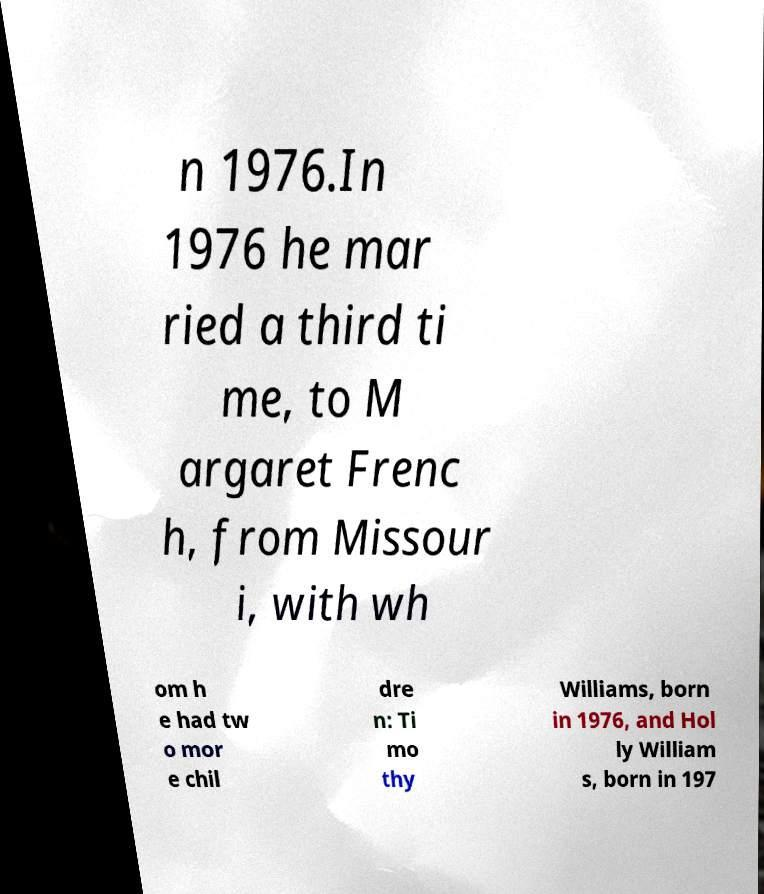Can you read and provide the text displayed in the image?This photo seems to have some interesting text. Can you extract and type it out for me? n 1976.In 1976 he mar ried a third ti me, to M argaret Frenc h, from Missour i, with wh om h e had tw o mor e chil dre n: Ti mo thy Williams, born in 1976, and Hol ly William s, born in 197 